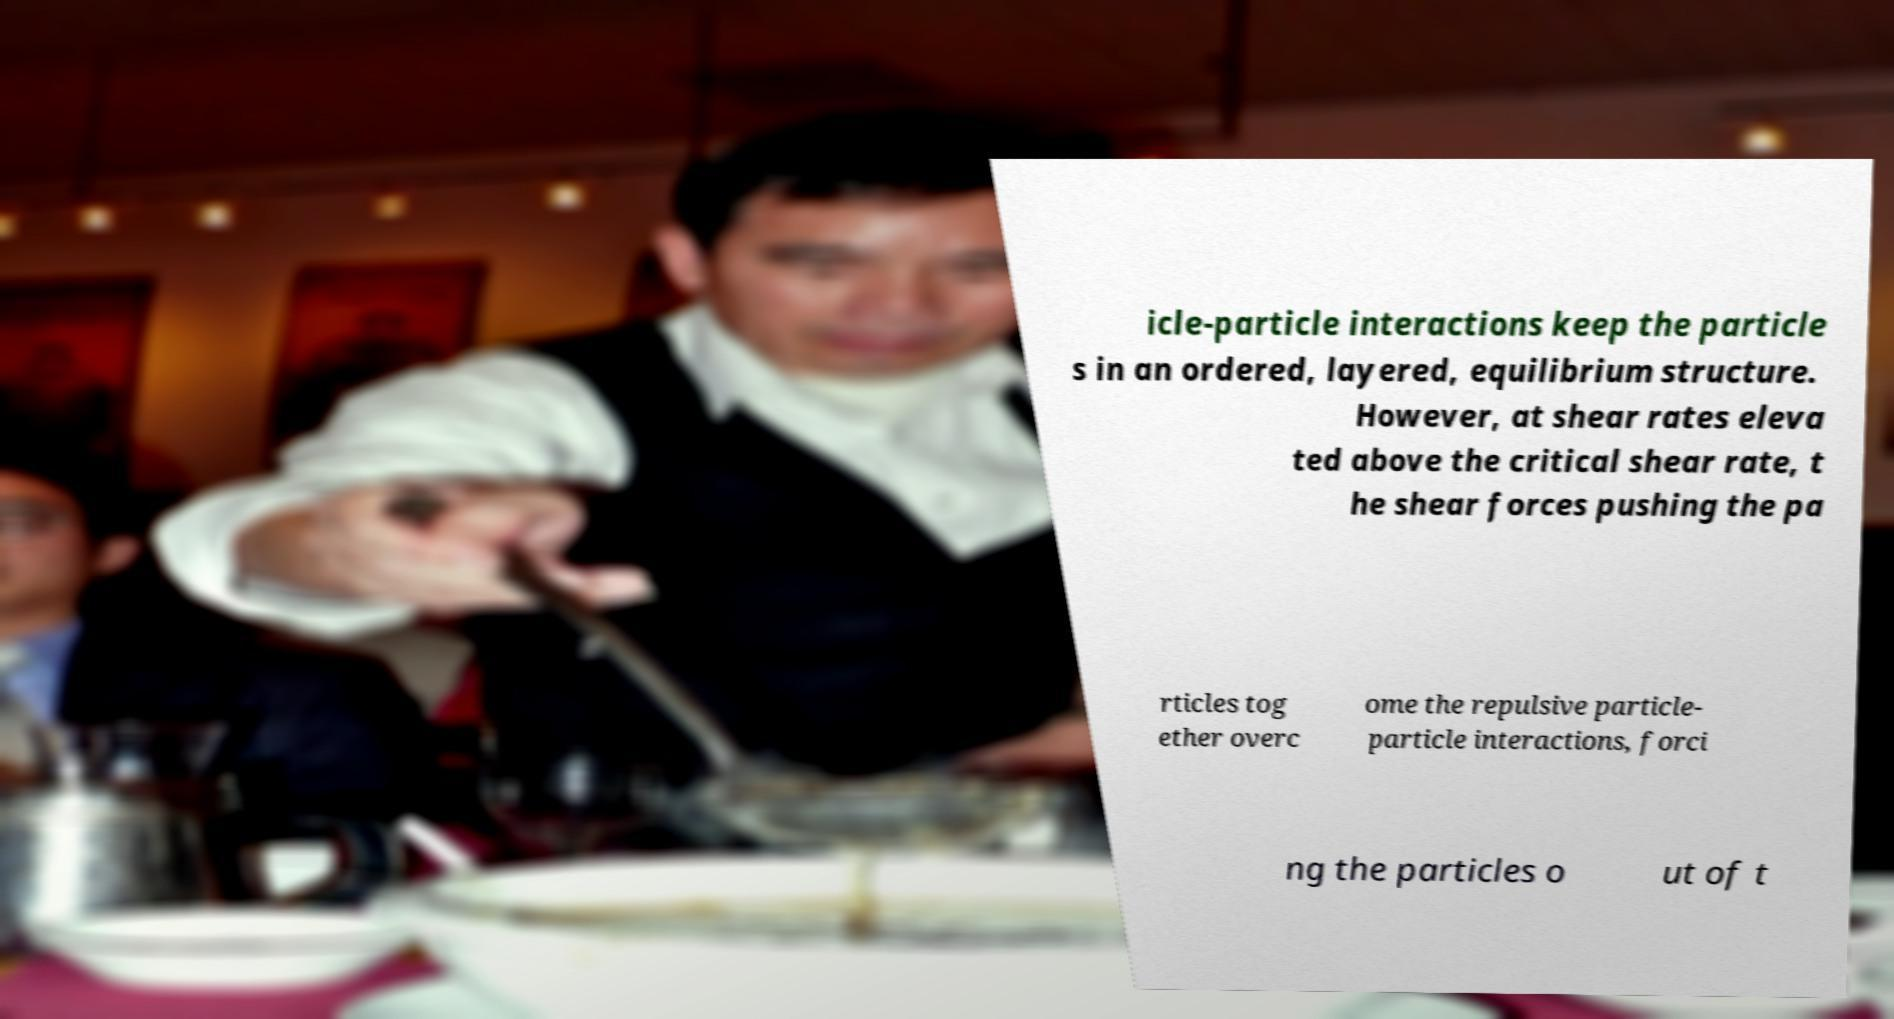I need the written content from this picture converted into text. Can you do that? icle-particle interactions keep the particle s in an ordered, layered, equilibrium structure. However, at shear rates eleva ted above the critical shear rate, t he shear forces pushing the pa rticles tog ether overc ome the repulsive particle- particle interactions, forci ng the particles o ut of t 